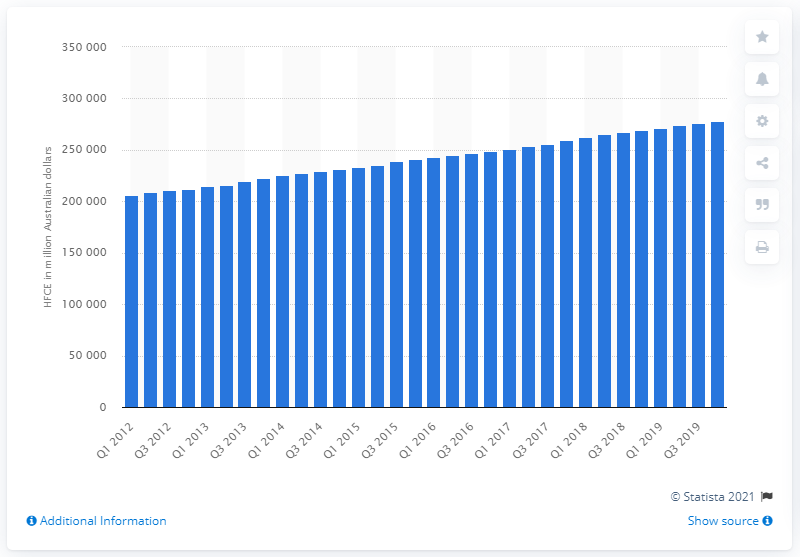Give some essential details in this illustration. The household final consumption expenditure of the fourth quarter of 2019 was 277,811. 